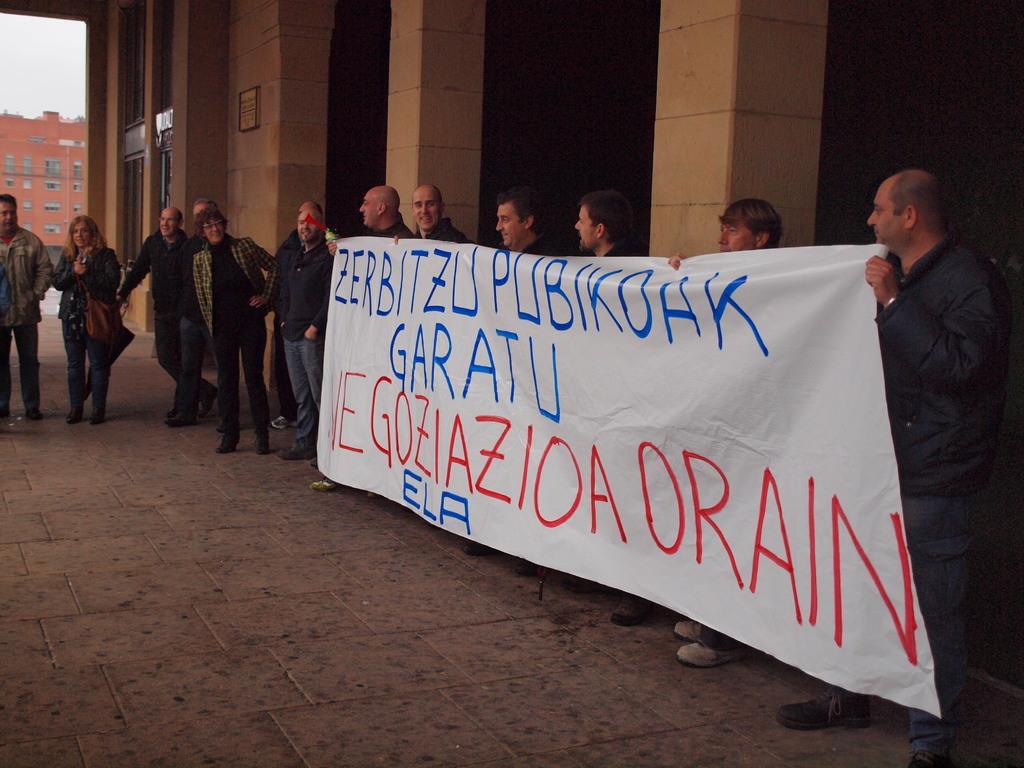Please provide a concise description of this image. In this picture I can observe some people holding a white color poster. There is some text on the poster. There are men and women in this picture. In the background there is a building and a sky. 